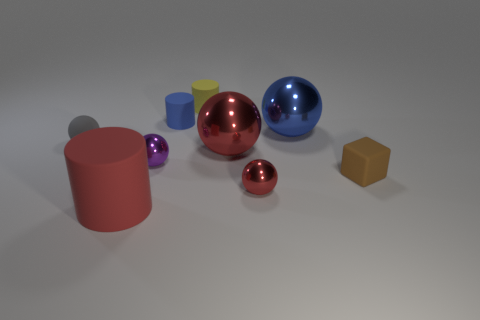Subtract all purple spheres. How many spheres are left? 4 Subtract 1 balls. How many balls are left? 4 Subtract all green balls. Subtract all purple cylinders. How many balls are left? 5 Subtract all balls. How many objects are left? 4 Add 2 tiny red rubber cylinders. How many tiny red rubber cylinders exist? 2 Subtract 1 red balls. How many objects are left? 8 Subtract all large blue spheres. Subtract all tiny purple matte things. How many objects are left? 8 Add 8 purple metal spheres. How many purple metal spheres are left? 9 